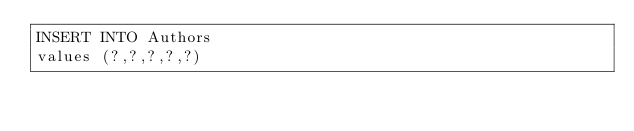<code> <loc_0><loc_0><loc_500><loc_500><_SQL_>INSERT INTO Authors
values (?,?,?,?,?)</code> 